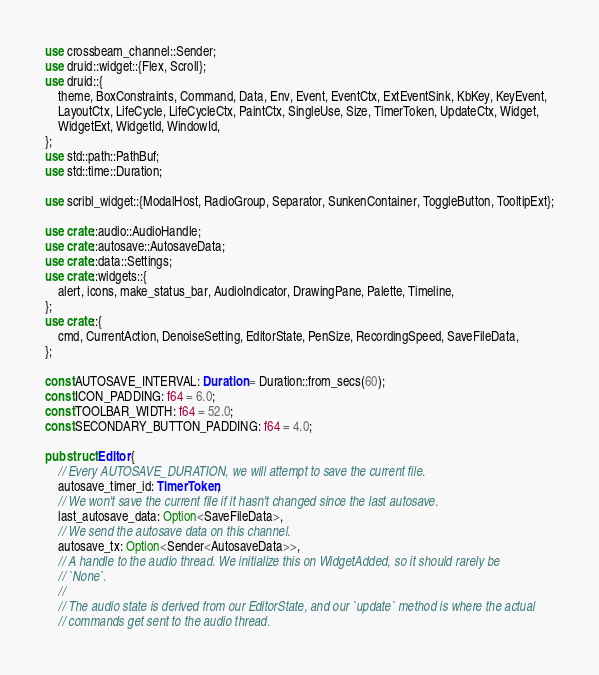Convert code to text. <code><loc_0><loc_0><loc_500><loc_500><_Rust_>use crossbeam_channel::Sender;
use druid::widget::{Flex, Scroll};
use druid::{
    theme, BoxConstraints, Command, Data, Env, Event, EventCtx, ExtEventSink, KbKey, KeyEvent,
    LayoutCtx, LifeCycle, LifeCycleCtx, PaintCtx, SingleUse, Size, TimerToken, UpdateCtx, Widget,
    WidgetExt, WidgetId, WindowId,
};
use std::path::PathBuf;
use std::time::Duration;

use scribl_widget::{ModalHost, RadioGroup, Separator, SunkenContainer, ToggleButton, TooltipExt};

use crate::audio::AudioHandle;
use crate::autosave::AutosaveData;
use crate::data::Settings;
use crate::widgets::{
    alert, icons, make_status_bar, AudioIndicator, DrawingPane, Palette, Timeline,
};
use crate::{
    cmd, CurrentAction, DenoiseSetting, EditorState, PenSize, RecordingSpeed, SaveFileData,
};

const AUTOSAVE_INTERVAL: Duration = Duration::from_secs(60);
const ICON_PADDING: f64 = 6.0;
const TOOLBAR_WIDTH: f64 = 52.0;
const SECONDARY_BUTTON_PADDING: f64 = 4.0;

pub struct Editor {
    // Every AUTOSAVE_DURATION, we will attempt to save the current file.
    autosave_timer_id: TimerToken,
    // We won't save the current file if it hasn't changed since the last autosave.
    last_autosave_data: Option<SaveFileData>,
    // We send the autosave data on this channel.
    autosave_tx: Option<Sender<AutosaveData>>,
    // A handle to the audio thread. We initialize this on WidgetAdded, so it should rarely be
    // `None`.
    //
    // The audio state is derived from our EditorState, and our `update` method is where the actual
    // commands get sent to the audio thread.</code> 